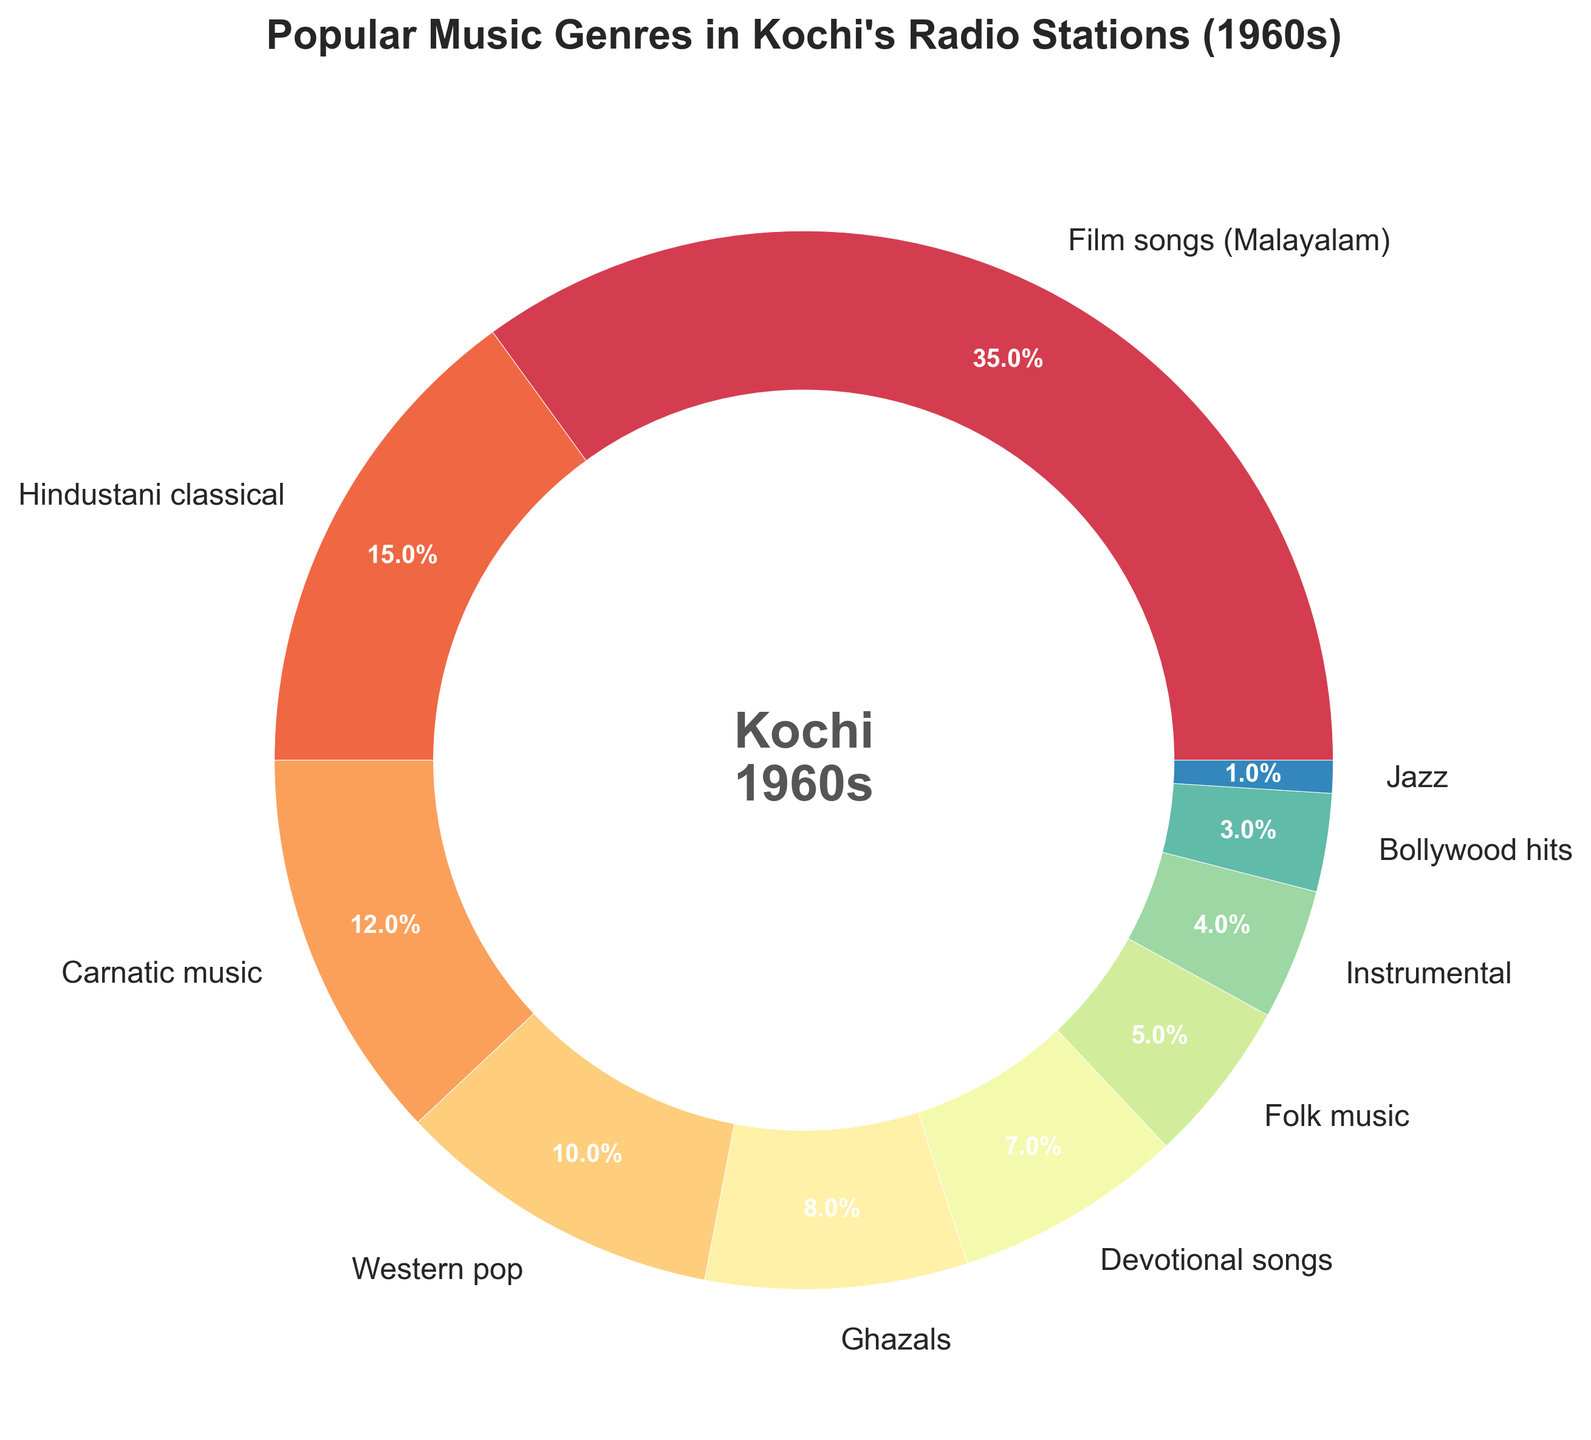What is the most popular music genre in Kochi's radio stations during the 1960s? The largest segment of the pie chart represents the most popular music genre. Looking at the chart, the biggest portion is labeled 'Film songs (Malayalam)', with a percentage of 35%.
Answer: Film songs (Malayalam) Which genre has the smallest share in Kochi's radio stations during the 1960s? The smallest slice of the pie chart represents the genre with the lowest percentage. This segment is labeled 'Jazz', with a percentage of 1%.
Answer: Jazz How much more popular are Film songs (Malayalam) compared to Hindustani classical? To find how much more popular Film songs (Malayalam) are, subtract the percentage of Hindustani classical from the percentage of Film songs (Malayalam): 35% - 15% = 20%.
Answer: 20% What is the combined percentage of Western pop and Jazz music? Add the percentages for Western pop and Jazz music: 10% (Western pop) + 1% (Jazz) = 11%.
Answer: 11% Which two genres together make up a total of 11%? Look for two segments in the pie chart whose percentages add up to 11%. The Western pop (10%) and Jazz (1%) segments fit this criterion.
Answer: Western pop and Jazz Is Carnatic music more or less popular than Ghazals? Compare the percentages of Carnatic music and Ghazals. Carnatic music has 12%, while Ghazals have 8%. Therefore, Carnatic music is more popular.
Answer: More popular How does the popularity of Folk music compare to Bollywood hits? Compare the percentages of Folk music and Bollywood hits. Folk music has 5%, while Bollywood hits have 3%. Therefore, Folk music is more popular.
Answer: More popular What is the difference in popularity between Devotional songs and Instrumental music? Subtract the percentage of Instrumental music from the percentage of Devotional songs: 7% - 4% = 3%.
Answer: 3% If you combine all Indian-based music genres (Film songs, Hindustani classical, Carnatic music, Ghazals, Devotional songs, Folk music, Bollywood hits), what is the total percentage? Sum the percentages of all Indian-based music genres listed: 35% + 15% + 12% + 8% + 7% + 5% + 3% = 85%.
Answer: 85% Which genres occupy an equal percentage of 8% or lower? Look for genres that have a percentage of 8% or lower in the pie chart. These genres are Ghazals (8%), Devotional songs (7%), Folk music (5%), Instrumental (4%), Bollywood hits (3%), and Jazz (1%).
Answer: Ghazals, Devotional songs, Folk music, Instrumental, Bollywood hits, Jazz 